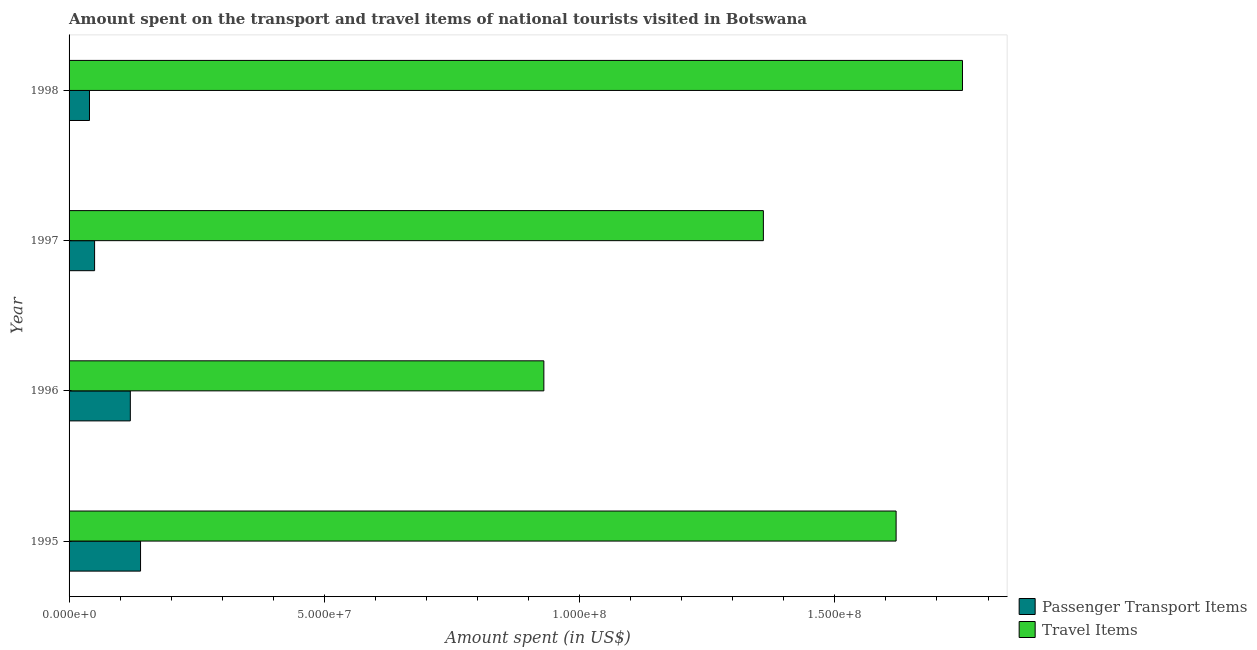How many different coloured bars are there?
Offer a very short reply. 2. Are the number of bars on each tick of the Y-axis equal?
Provide a short and direct response. Yes. How many bars are there on the 2nd tick from the top?
Your response must be concise. 2. What is the label of the 1st group of bars from the top?
Give a very brief answer. 1998. What is the amount spent in travel items in 1997?
Ensure brevity in your answer.  1.36e+08. Across all years, what is the maximum amount spent in travel items?
Make the answer very short. 1.75e+08. Across all years, what is the minimum amount spent in travel items?
Your answer should be compact. 9.30e+07. What is the total amount spent on passenger transport items in the graph?
Offer a very short reply. 3.50e+07. What is the difference between the amount spent in travel items in 1995 and that in 1997?
Provide a short and direct response. 2.60e+07. What is the difference between the amount spent on passenger transport items in 1998 and the amount spent in travel items in 1997?
Provide a short and direct response. -1.32e+08. What is the average amount spent on passenger transport items per year?
Ensure brevity in your answer.  8.75e+06. In the year 1996, what is the difference between the amount spent in travel items and amount spent on passenger transport items?
Offer a terse response. 8.10e+07. In how many years, is the amount spent on passenger transport items greater than 140000000 US$?
Your answer should be compact. 0. What is the ratio of the amount spent in travel items in 1996 to that in 1998?
Give a very brief answer. 0.53. Is the amount spent on passenger transport items in 1996 less than that in 1998?
Give a very brief answer. No. Is the difference between the amount spent on passenger transport items in 1995 and 1998 greater than the difference between the amount spent in travel items in 1995 and 1998?
Provide a short and direct response. Yes. What is the difference between the highest and the second highest amount spent on passenger transport items?
Your answer should be very brief. 2.00e+06. What is the difference between the highest and the lowest amount spent in travel items?
Your answer should be compact. 8.20e+07. Is the sum of the amount spent in travel items in 1995 and 1996 greater than the maximum amount spent on passenger transport items across all years?
Offer a very short reply. Yes. What does the 1st bar from the top in 1998 represents?
Offer a terse response. Travel Items. What does the 1st bar from the bottom in 1996 represents?
Your response must be concise. Passenger Transport Items. What is the difference between two consecutive major ticks on the X-axis?
Offer a terse response. 5.00e+07. Are the values on the major ticks of X-axis written in scientific E-notation?
Offer a very short reply. Yes. Does the graph contain any zero values?
Your answer should be compact. No. Does the graph contain grids?
Your answer should be very brief. No. Where does the legend appear in the graph?
Offer a terse response. Bottom right. How are the legend labels stacked?
Provide a short and direct response. Vertical. What is the title of the graph?
Keep it short and to the point. Amount spent on the transport and travel items of national tourists visited in Botswana. What is the label or title of the X-axis?
Provide a succinct answer. Amount spent (in US$). What is the Amount spent (in US$) of Passenger Transport Items in 1995?
Give a very brief answer. 1.40e+07. What is the Amount spent (in US$) of Travel Items in 1995?
Provide a succinct answer. 1.62e+08. What is the Amount spent (in US$) in Passenger Transport Items in 1996?
Your answer should be compact. 1.20e+07. What is the Amount spent (in US$) in Travel Items in 1996?
Provide a short and direct response. 9.30e+07. What is the Amount spent (in US$) of Passenger Transport Items in 1997?
Your answer should be very brief. 5.00e+06. What is the Amount spent (in US$) in Travel Items in 1997?
Ensure brevity in your answer.  1.36e+08. What is the Amount spent (in US$) in Travel Items in 1998?
Keep it short and to the point. 1.75e+08. Across all years, what is the maximum Amount spent (in US$) in Passenger Transport Items?
Offer a very short reply. 1.40e+07. Across all years, what is the maximum Amount spent (in US$) in Travel Items?
Keep it short and to the point. 1.75e+08. Across all years, what is the minimum Amount spent (in US$) of Passenger Transport Items?
Provide a succinct answer. 4.00e+06. Across all years, what is the minimum Amount spent (in US$) in Travel Items?
Give a very brief answer. 9.30e+07. What is the total Amount spent (in US$) of Passenger Transport Items in the graph?
Give a very brief answer. 3.50e+07. What is the total Amount spent (in US$) in Travel Items in the graph?
Provide a succinct answer. 5.66e+08. What is the difference between the Amount spent (in US$) in Travel Items in 1995 and that in 1996?
Your answer should be compact. 6.90e+07. What is the difference between the Amount spent (in US$) in Passenger Transport Items in 1995 and that in 1997?
Your answer should be compact. 9.00e+06. What is the difference between the Amount spent (in US$) in Travel Items in 1995 and that in 1997?
Your response must be concise. 2.60e+07. What is the difference between the Amount spent (in US$) in Travel Items in 1995 and that in 1998?
Your response must be concise. -1.30e+07. What is the difference between the Amount spent (in US$) in Passenger Transport Items in 1996 and that in 1997?
Offer a very short reply. 7.00e+06. What is the difference between the Amount spent (in US$) of Travel Items in 1996 and that in 1997?
Your answer should be very brief. -4.30e+07. What is the difference between the Amount spent (in US$) in Passenger Transport Items in 1996 and that in 1998?
Your answer should be very brief. 8.00e+06. What is the difference between the Amount spent (in US$) in Travel Items in 1996 and that in 1998?
Your answer should be compact. -8.20e+07. What is the difference between the Amount spent (in US$) in Passenger Transport Items in 1997 and that in 1998?
Offer a terse response. 1.00e+06. What is the difference between the Amount spent (in US$) of Travel Items in 1997 and that in 1998?
Ensure brevity in your answer.  -3.90e+07. What is the difference between the Amount spent (in US$) of Passenger Transport Items in 1995 and the Amount spent (in US$) of Travel Items in 1996?
Make the answer very short. -7.90e+07. What is the difference between the Amount spent (in US$) in Passenger Transport Items in 1995 and the Amount spent (in US$) in Travel Items in 1997?
Your response must be concise. -1.22e+08. What is the difference between the Amount spent (in US$) of Passenger Transport Items in 1995 and the Amount spent (in US$) of Travel Items in 1998?
Keep it short and to the point. -1.61e+08. What is the difference between the Amount spent (in US$) in Passenger Transport Items in 1996 and the Amount spent (in US$) in Travel Items in 1997?
Ensure brevity in your answer.  -1.24e+08. What is the difference between the Amount spent (in US$) of Passenger Transport Items in 1996 and the Amount spent (in US$) of Travel Items in 1998?
Provide a succinct answer. -1.63e+08. What is the difference between the Amount spent (in US$) of Passenger Transport Items in 1997 and the Amount spent (in US$) of Travel Items in 1998?
Your answer should be very brief. -1.70e+08. What is the average Amount spent (in US$) in Passenger Transport Items per year?
Your response must be concise. 8.75e+06. What is the average Amount spent (in US$) in Travel Items per year?
Provide a succinct answer. 1.42e+08. In the year 1995, what is the difference between the Amount spent (in US$) in Passenger Transport Items and Amount spent (in US$) in Travel Items?
Offer a very short reply. -1.48e+08. In the year 1996, what is the difference between the Amount spent (in US$) of Passenger Transport Items and Amount spent (in US$) of Travel Items?
Provide a short and direct response. -8.10e+07. In the year 1997, what is the difference between the Amount spent (in US$) of Passenger Transport Items and Amount spent (in US$) of Travel Items?
Your answer should be very brief. -1.31e+08. In the year 1998, what is the difference between the Amount spent (in US$) in Passenger Transport Items and Amount spent (in US$) in Travel Items?
Make the answer very short. -1.71e+08. What is the ratio of the Amount spent (in US$) of Travel Items in 1995 to that in 1996?
Provide a succinct answer. 1.74. What is the ratio of the Amount spent (in US$) in Travel Items in 1995 to that in 1997?
Your answer should be very brief. 1.19. What is the ratio of the Amount spent (in US$) of Travel Items in 1995 to that in 1998?
Your answer should be compact. 0.93. What is the ratio of the Amount spent (in US$) in Travel Items in 1996 to that in 1997?
Keep it short and to the point. 0.68. What is the ratio of the Amount spent (in US$) of Travel Items in 1996 to that in 1998?
Provide a succinct answer. 0.53. What is the ratio of the Amount spent (in US$) of Travel Items in 1997 to that in 1998?
Offer a very short reply. 0.78. What is the difference between the highest and the second highest Amount spent (in US$) of Travel Items?
Give a very brief answer. 1.30e+07. What is the difference between the highest and the lowest Amount spent (in US$) in Passenger Transport Items?
Keep it short and to the point. 1.00e+07. What is the difference between the highest and the lowest Amount spent (in US$) of Travel Items?
Your response must be concise. 8.20e+07. 